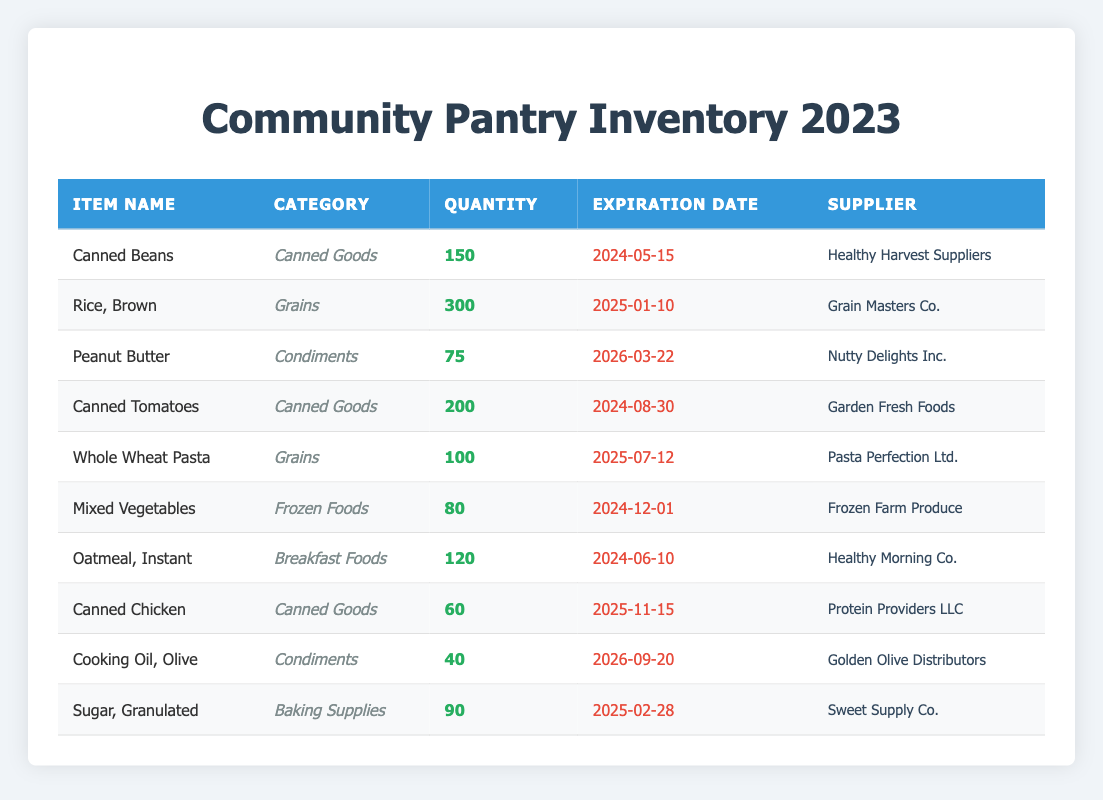What is the total quantity of Canned Goods in inventory? To find the total quantity of Canned Goods, I look for items under the "Canned Goods" category in the table. There are three items: Canned Beans (150), Canned Tomatoes (200), and Canned Chicken (60). Adding them together: 150 + 200 + 60 = 410.
Answer: 410 Which item has the earliest expiration date? To determine the item with the earliest expiration date, I examine the expiration date column and look for the smallest date. The dates are 2024-05-15 (Canned Beans), 2024-08-30 (Canned Tomatoes), 2024-06-10 (Oatmeal, Instant), 2024-12-01 (Mixed Vegetables), etc. Canned Beans has the earliest expiration date of 2024-05-15.
Answer: Canned Beans Is there any item expiring in the year 2025? I need to check the expiration date column for any items with dates in the year 2025. I see Rice, Brown (2025-01-10), Whole Wheat Pasta (2025-07-12), Canned Chicken (2025-11-15), Sugar, Granulated (2025-02-28). Since these items fall in 2025, the answer is yes.
Answer: Yes What is the total quantity of Grains and Condiments combined? First, I identify the items in the Grains category: Rice, Brown (300) and Whole Wheat Pasta (100), totaling 300 + 100 = 400. For Condiments, I locate Peanut Butter (75) and Cooking Oil, Olive (40), totaling 75 + 40 = 115. Now, I add the two totals together: 400 + 115 = 515.
Answer: 515 How many items have a quantity less than 100? I inspect the quantity column for items with a value less than 100. The items with lower quantities are Mixed Vegetables (80), Peanut Butter (75), and Cooking Oil, Olive (40). That gives us three items with a quantity under 100.
Answer: 3 Are there more items supplied by Healthy Harvest Suppliers than by any other supplier? I look through the supplier column to count how many items are associated with Healthy Harvest Suppliers. There is 1 item (Canned Beans). For other suppliers, Grain Masters Co. has 1 item, Nutty Delights Inc. has 1 item, Garden Fresh Foods has 1 item, Pasta Perfection Ltd. has 1 item, Frozen Farm Produce has 1 item, Protein Providers LLC has 1 item, Golden Olive Distributors has 1 item, and Sweet Supply Co. has 1 item. Each supplier only has 1 item. Therefore, the answer is no, there are not more items from Healthy Harvest Suppliers.
Answer: No What is the average quantity of Frozen Foods and Breakfast Foods? First, I look for the quantities in the Frozen Foods category, which has Mixed Vegetables (80), and for Breakfast Foods, there is Oatmeal, Instant (120). I sum these quantities: 80 + 120 = 200. Since there are 2 items, I divide the total by 2 to find the average: 200 / 2 = 100.
Answer: 100 Which supplier provides the item with the highest quantity? I need to determine the item that has the highest quantity in the inventory. The highest quantity belongs to Rice, Brown at 300. The supplier for this item is Grain Masters Co. Therefore, the answer is Grain Masters Co.
Answer: Grain Masters Co 